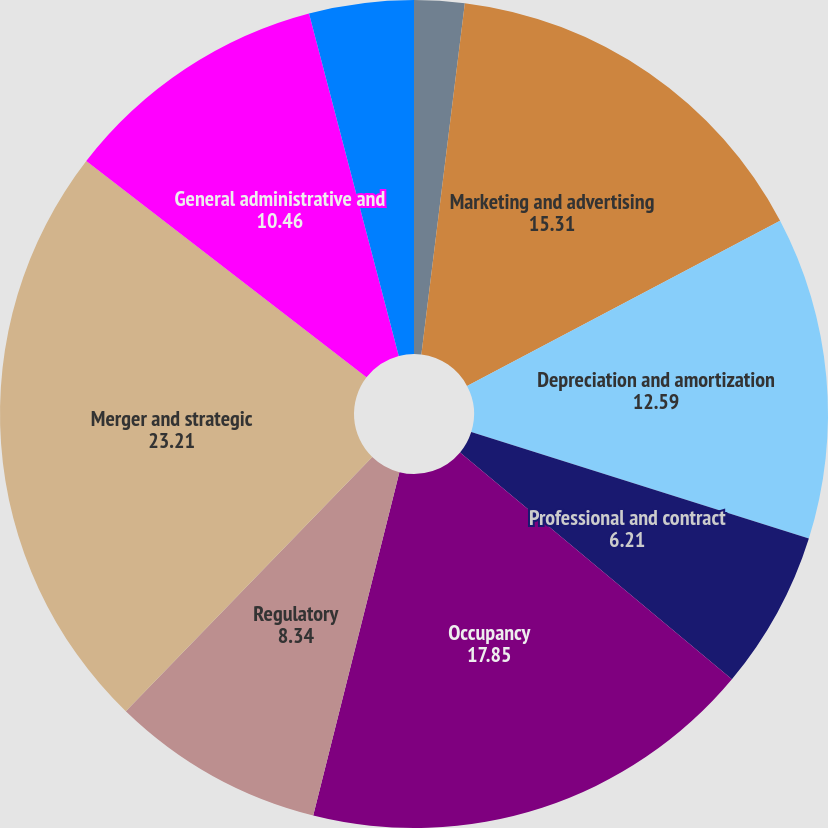Convert chart to OTSL. <chart><loc_0><loc_0><loc_500><loc_500><pie_chart><fcel>Compensation and benefits<fcel>Marketing and advertising<fcel>Depreciation and amortization<fcel>Professional and contract<fcel>Occupancy<fcel>Regulatory<fcel>Merger and strategic<fcel>General administrative and<fcel>Total operating expenses<nl><fcel>1.96%<fcel>15.31%<fcel>12.59%<fcel>6.21%<fcel>17.85%<fcel>8.34%<fcel>23.21%<fcel>10.46%<fcel>4.08%<nl></chart> 